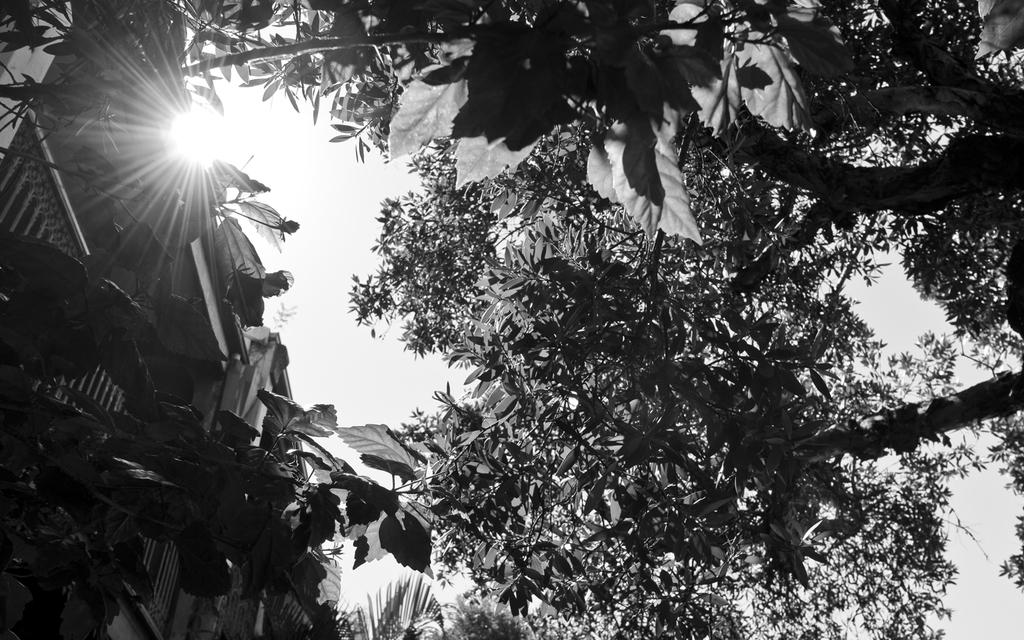What is the color scheme of the image? The image is black and white. What type of vegetation can be seen on the right side of the image? There are trees on the right side of the image. What type of structure is located on the left side of the image? There is a building on the left side of the image. What can be seen in the sky at the top of the image? Sun rays are visible at the top of the image. What type of behavior does the crow exhibit in the image? There is no crow present in the image, so it is not possible to describe its behavior. 